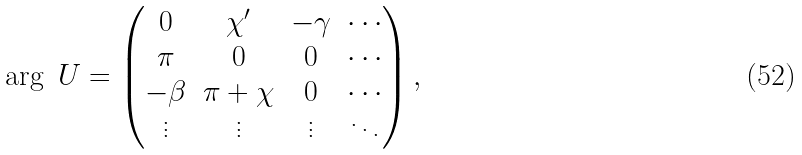<formula> <loc_0><loc_0><loc_500><loc_500>\arg \ U = \begin{pmatrix} 0 & \chi ^ { \prime } & - \gamma & \cdots \\ \pi & 0 & 0 & \cdots \\ - \beta & \pi + \chi & 0 & \cdots \\ \vdots & \vdots & \vdots & \ddots \end{pmatrix} ,</formula> 